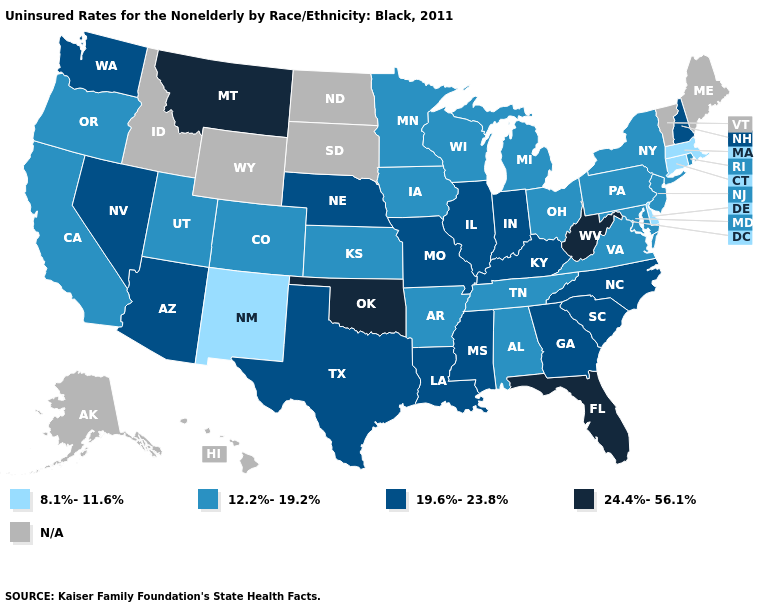What is the value of Maine?
Quick response, please. N/A. What is the value of Idaho?
Write a very short answer. N/A. Name the states that have a value in the range 19.6%-23.8%?
Give a very brief answer. Arizona, Georgia, Illinois, Indiana, Kentucky, Louisiana, Mississippi, Missouri, Nebraska, Nevada, New Hampshire, North Carolina, South Carolina, Texas, Washington. What is the highest value in the MidWest ?
Short answer required. 19.6%-23.8%. Which states have the highest value in the USA?
Keep it brief. Florida, Montana, Oklahoma, West Virginia. Which states have the highest value in the USA?
Give a very brief answer. Florida, Montana, Oklahoma, West Virginia. Among the states that border Arkansas , which have the highest value?
Answer briefly. Oklahoma. How many symbols are there in the legend?
Concise answer only. 5. Which states have the lowest value in the MidWest?
Quick response, please. Iowa, Kansas, Michigan, Minnesota, Ohio, Wisconsin. What is the highest value in states that border Delaware?
Concise answer only. 12.2%-19.2%. How many symbols are there in the legend?
Keep it brief. 5. Which states have the lowest value in the USA?
Give a very brief answer. Connecticut, Delaware, Massachusetts, New Mexico. 